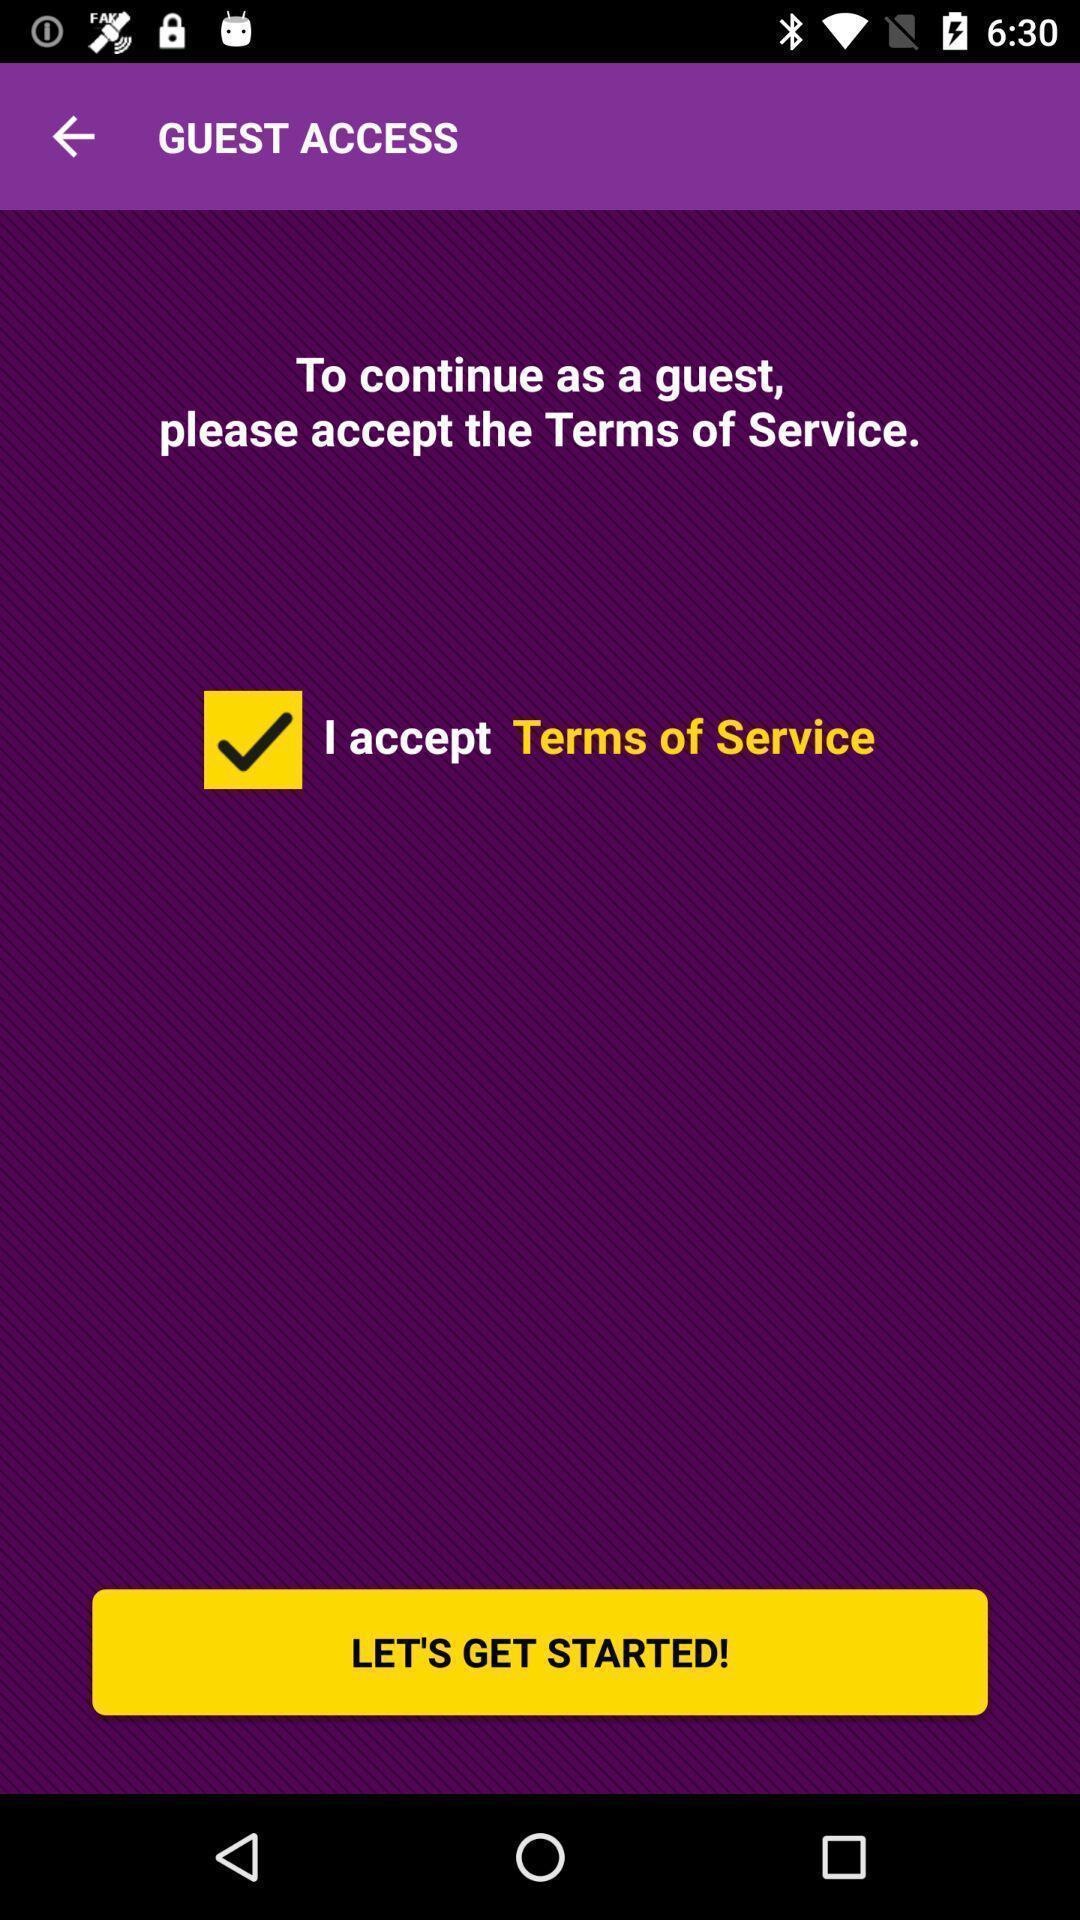Describe the key features of this screenshot. Starting page. 